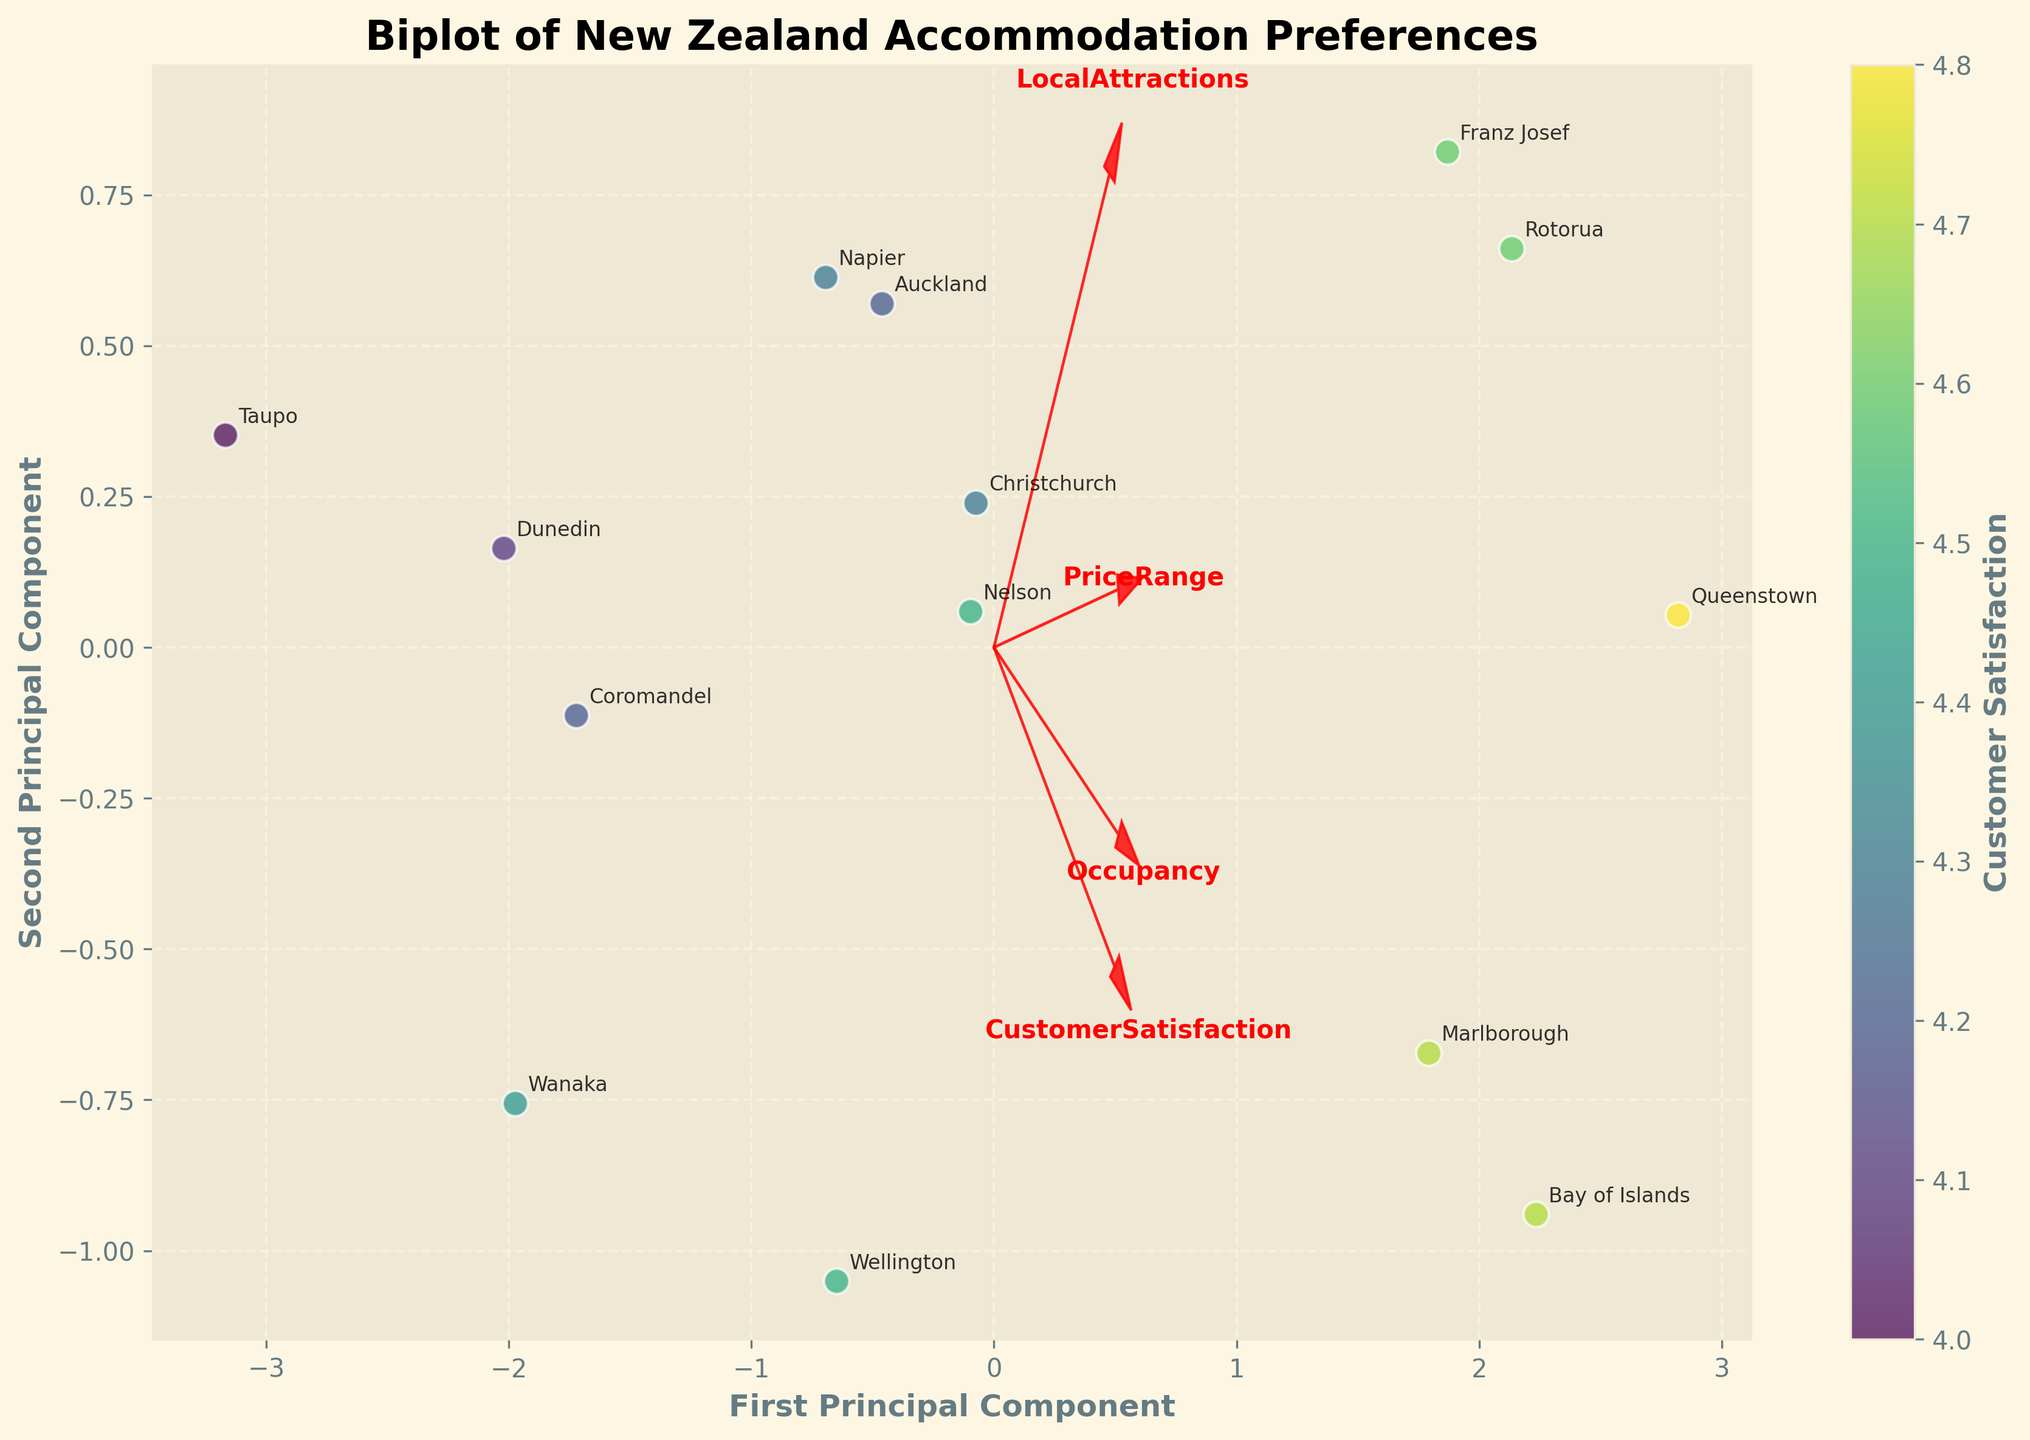How many accommodation types are marked on the plot? Count all distinct labeled regions representing different accommodation types.
Answer: 14 Which region has the highest Customer Satisfaction rating? The Customer Satisfaction rating is color-coded, with Queenstown having the darkest color, implying the highest rating.
Answer: Queenstown Which features are represented by the red arrows on the plot? Identify the text labels at the ends of the red arrows.
Answer: Customer Satisfaction, Price Range, Occupancy, Local Attractions What is the approximate Principal Component value of Queenstown along the First Principal Component axis? Locate Queenstown on the plot and read off its x-coordinate value.
Answer: ~2.5 How do Luxury Resorts and Eco-Lodges compare in terms of their Principal Component positions? Locate the respective points for Queenstown (Luxury Resorts) and Nelson (Eco-Lodges) on the plot and compare their PC values.
Answer: Luxury Resorts are further along both PC axes Which accommodation type has the lowest occupancy? Identify the position and label for the point closest to the negative side of the Occupancy arrow.
Answer: Taupo (Lakefront Motel) Which feature vector points most closely in the same direction as the highest Customer Satisfaction ratings? Observe the orientation of the feature vectors and the direction indicated by the color gradient.
Answer: Customer Satisfaction What is the relationship between the Price Range and the First Principal Component? Observe the orientation of the Price Range vector relative to the First Principal Component.
Answer: Positive correlation If you were to move from a region with an Urban Hotel to a Beach House, how would the Principal Components change? Compare the positions of Auckland (Urban Hotel) and Coromandel (Beach House) on the PCA plot.
Answer: The First PC decreases, and the Second PC slightly increases Which regions are closely related when considering high Local Attractions score? Identify points near the vector indicating high values of Local Attractions.
Answer: Queenstown, Rotorua, and Franz Josef 